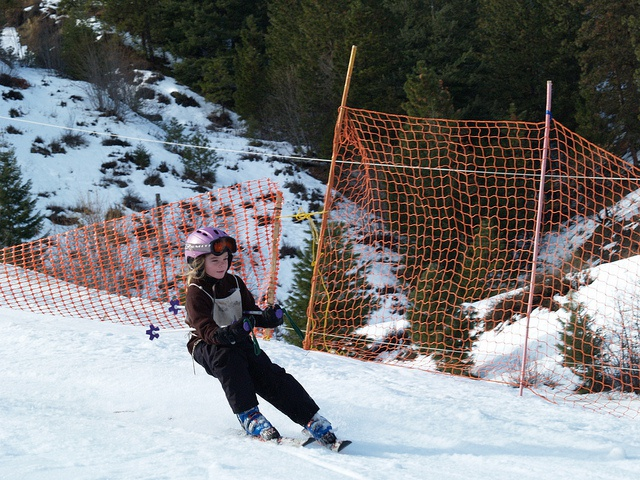Describe the objects in this image and their specific colors. I can see people in black, gray, darkgray, and lavender tones and skis in black, darkgray, lightgray, and gray tones in this image. 